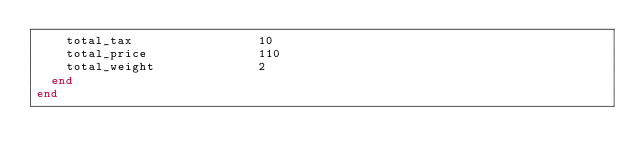<code> <loc_0><loc_0><loc_500><loc_500><_Ruby_>    total_tax                 10
    total_price               110
    total_weight              2
  end
end
</code> 